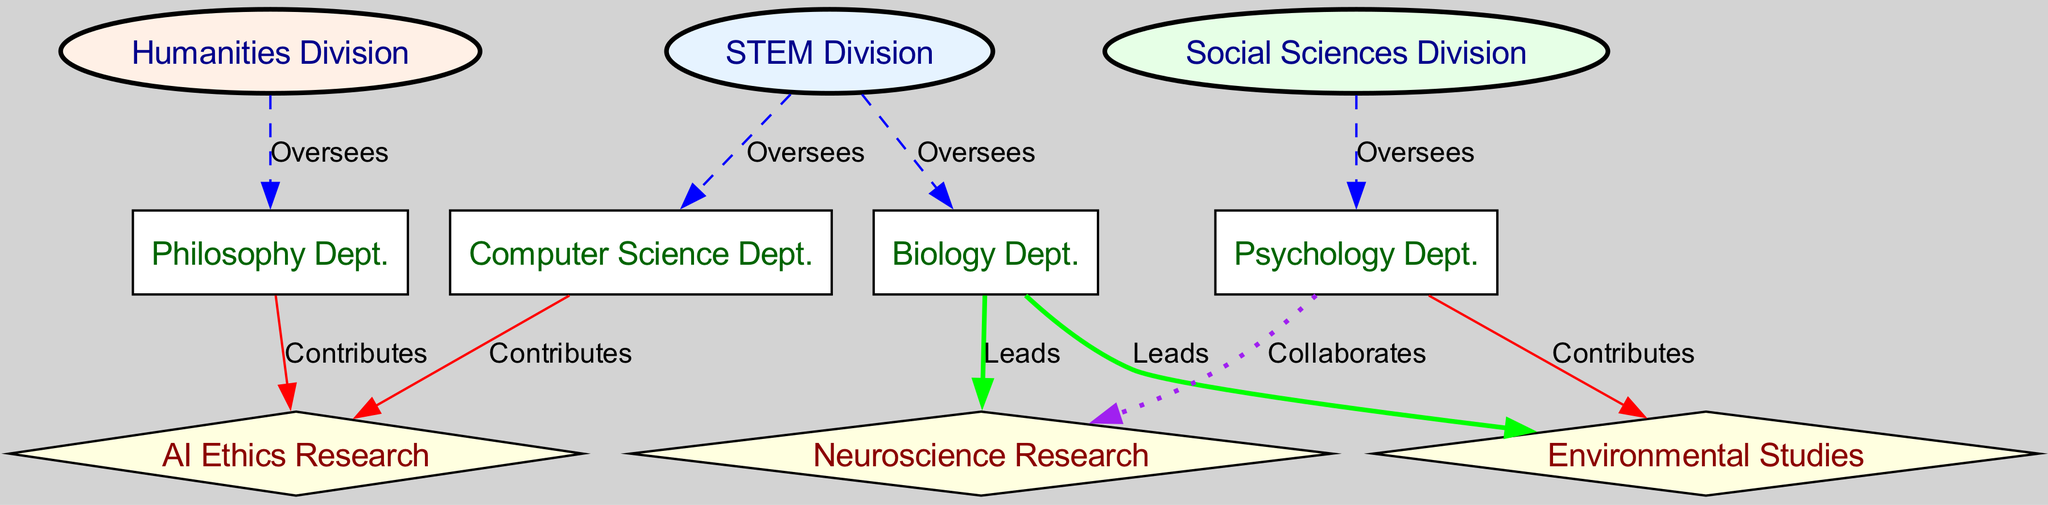What is the label of the node representing the Computer Science Department? The node for the Computer Science Department is labeled "Computer Science Dept."
Answer: Computer Science Dept How many departments are overseen by the STEM Division? The STEM Division oversees two departments: Computer Science and Biology.
Answer: 2 Which department contributes to AI Ethics Research? Both the Computer Science Department and the Philosophy Department contribute to AI Ethics Research.
Answer: Computer Science Dept., Philosophy Dept What is the relationship between the Biology Department and the Neuroscience Research? The Biology Department leads the Neuroscience Research, as indicated by the edge labeled "Leads."
Answer: Leads Which two divisions oversee Psychology Department? The Psychology Department is overseen by the Social Sciences Division and indirectly through collaborations from STEM Division nodes.
Answer: Social Sciences Division What colors are used for the Humanities Division in the diagram? The Humanities Division node is colored in a light peach using the color scheme defined for that division.
Answer: Light peach Which department leads Environmental Studies? The Biology Department leads Environmental Studies, as denoted by the connection labeled "Leads."
Answer: Biology Dept How many edges are there in total in the graph? Counting each connection between nodes, there are 10 edges in total shown in the diagram.
Answer: 10 What type of relationship exists between the Psychology Department and the Environmental Studies? The Psychology Department contributes to Environmental Studies, as designated by the edge labeled "Contributes."
Answer: Contributes Which divisions do the various departments belong to? The Computer Science and Biology Departments are part of the STEM Division, the Philosophy Department belongs to the Humanities Division, and the Psychology Department is in the Social Sciences Division.
Answer: STEM, Humanities, Social Sciences 